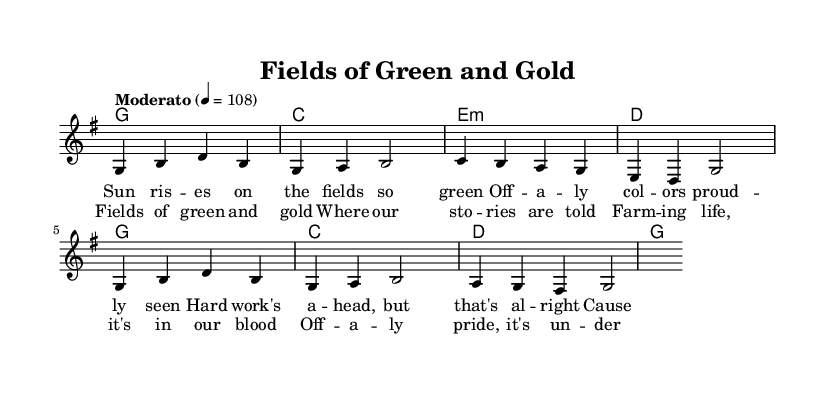What is the key signature of this music? The key signature is G major, which contains one sharp (F#). This can be verified by looking at the beginning of the staff where the sharp is indicated.
Answer: G major What is the time signature of this piece? The time signature is 4/4, which means there are four beats in each measure, and the quarter note gets one beat. This is indicated at the beginning of the sheet music.
Answer: 4/4 What is the tempo marking for this song? The tempo marking is "Moderato," set at a value of 108. This indicates a moderate pace for the performance. The tempo is shown near the beginning of the score.
Answer: Moderato How many measures are in the melody? The melody consists of eight measures, which can be counted by grouping the notes and looking at the bar lines that separate each measure.
Answer: Eight What is the main theme of the lyrics in the chorus? The main theme of the lyrics in the chorus is celebrating rural life and farming pride. The lyrics highlight the connection to nature and community, which is a central aspect of country music. This can be deduced by reading the words of the chorus provided below the staff.
Answer: Rural life and farming pride What kind of chord progression is used in the harmonies? The chord progression follows a common pattern in country music, mainly using the I-IV-V chords along with the minor chord for emotional effect. This can be analyzed by observing the chords written above the melody line throughout the piece.
Answer: I-IV-V 